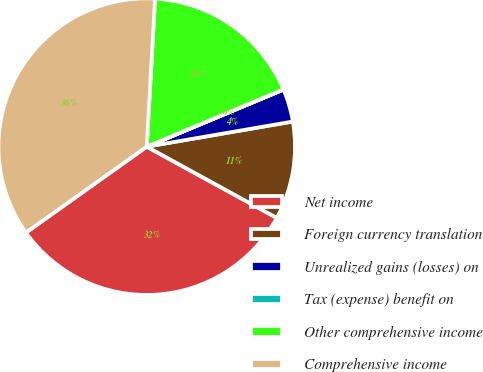Convert chart. <chart><loc_0><loc_0><loc_500><loc_500><pie_chart><fcel>Net income<fcel>Foreign currency translation<fcel>Unrealized gains (losses) on<fcel>Tax (expense) benefit on<fcel>Other comprehensive income<fcel>Comprehensive income<nl><fcel>32.18%<fcel>10.69%<fcel>3.58%<fcel>0.02%<fcel>17.79%<fcel>35.74%<nl></chart> 